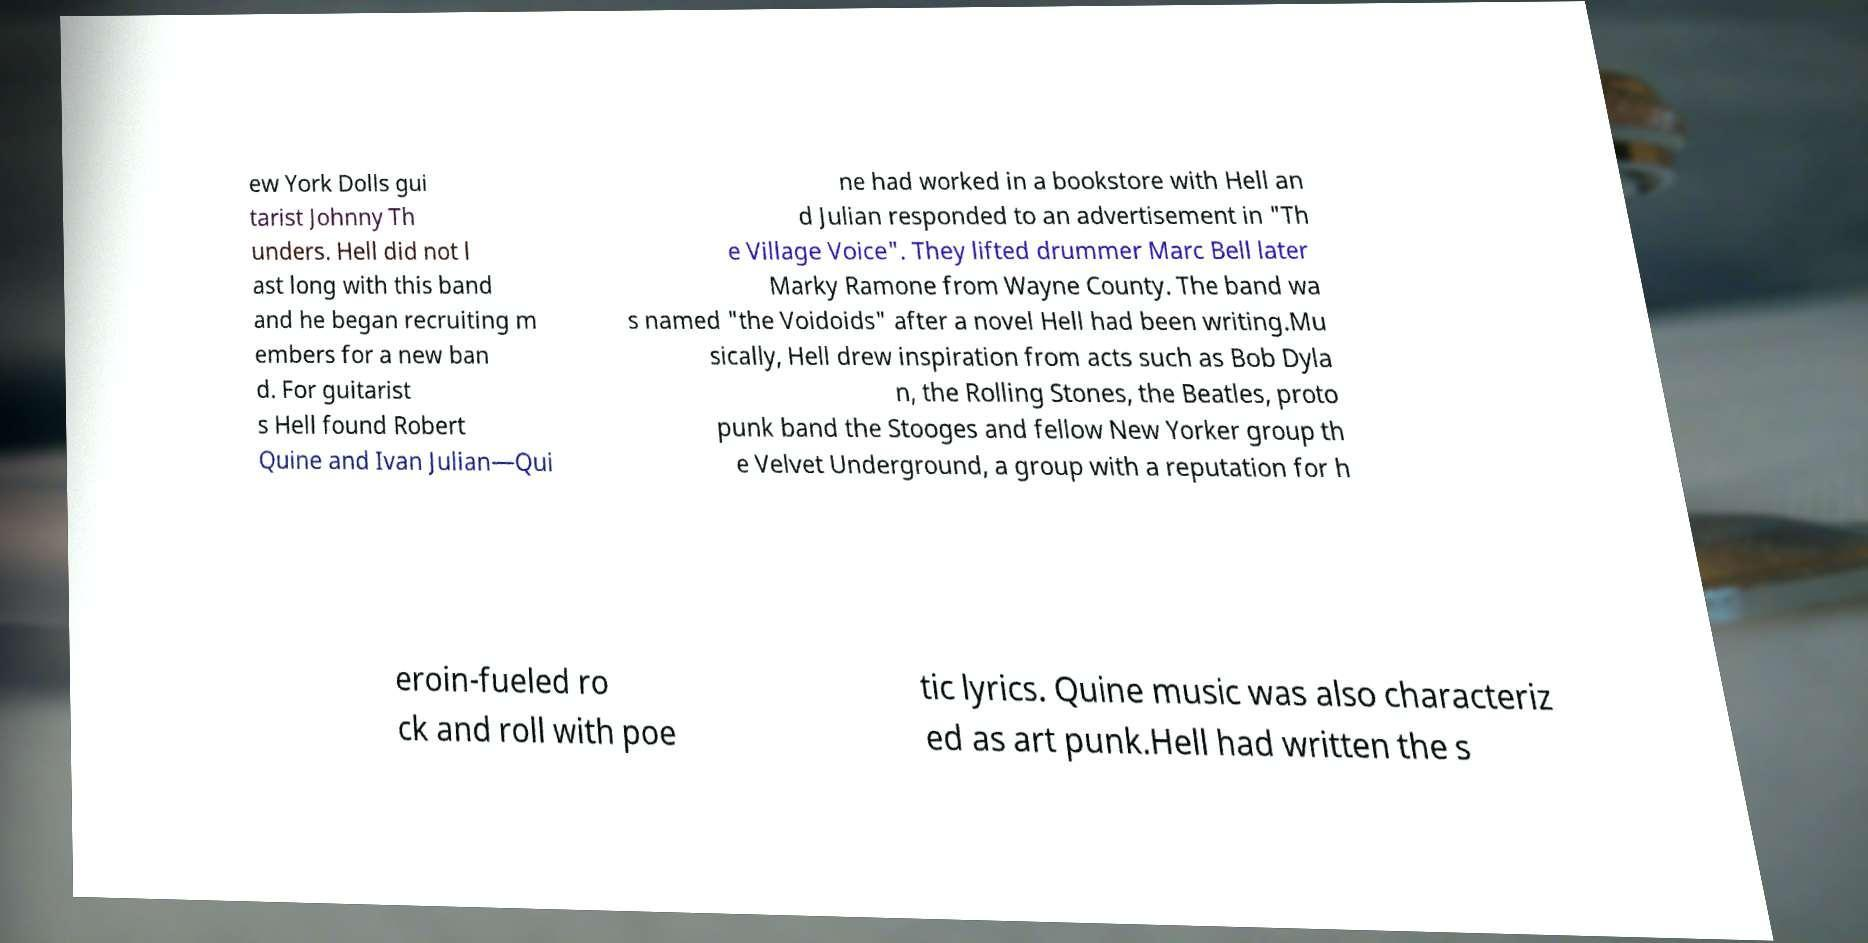Please identify and transcribe the text found in this image. ew York Dolls gui tarist Johnny Th unders. Hell did not l ast long with this band and he began recruiting m embers for a new ban d. For guitarist s Hell found Robert Quine and Ivan Julian—Qui ne had worked in a bookstore with Hell an d Julian responded to an advertisement in "Th e Village Voice". They lifted drummer Marc Bell later Marky Ramone from Wayne County. The band wa s named "the Voidoids" after a novel Hell had been writing.Mu sically, Hell drew inspiration from acts such as Bob Dyla n, the Rolling Stones, the Beatles, proto punk band the Stooges and fellow New Yorker group th e Velvet Underground, a group with a reputation for h eroin-fueled ro ck and roll with poe tic lyrics. Quine music was also characteriz ed as art punk.Hell had written the s 